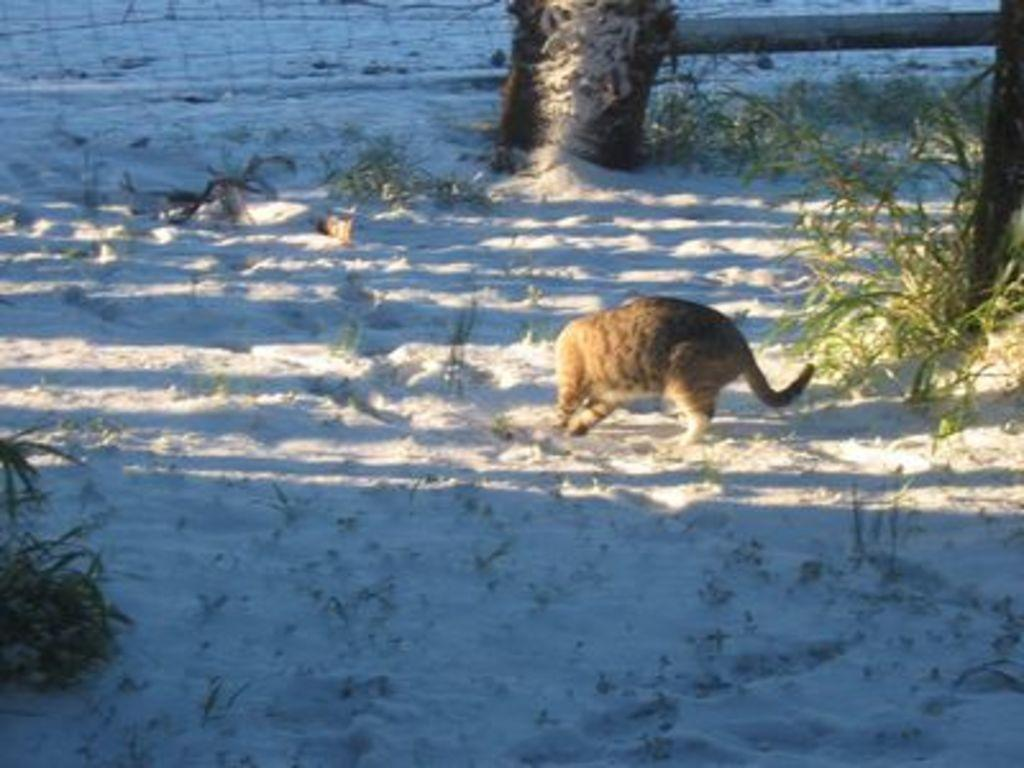What type of animal can be seen in the image? There is an animal in the image, but its specific type cannot be determined from the provided facts. What color is the animal in the image? The animal is brown in color. What can be seen in the background of the image? There are plants in the background of the image. What color are the plants in the image? The plants are green in color. What architectural feature is visible in the image? There is a railing visible in the image. What type of creature can be seen running on the moon in the image? There is no creature running on the moon in the image; it features an animal and plants on Earth. 